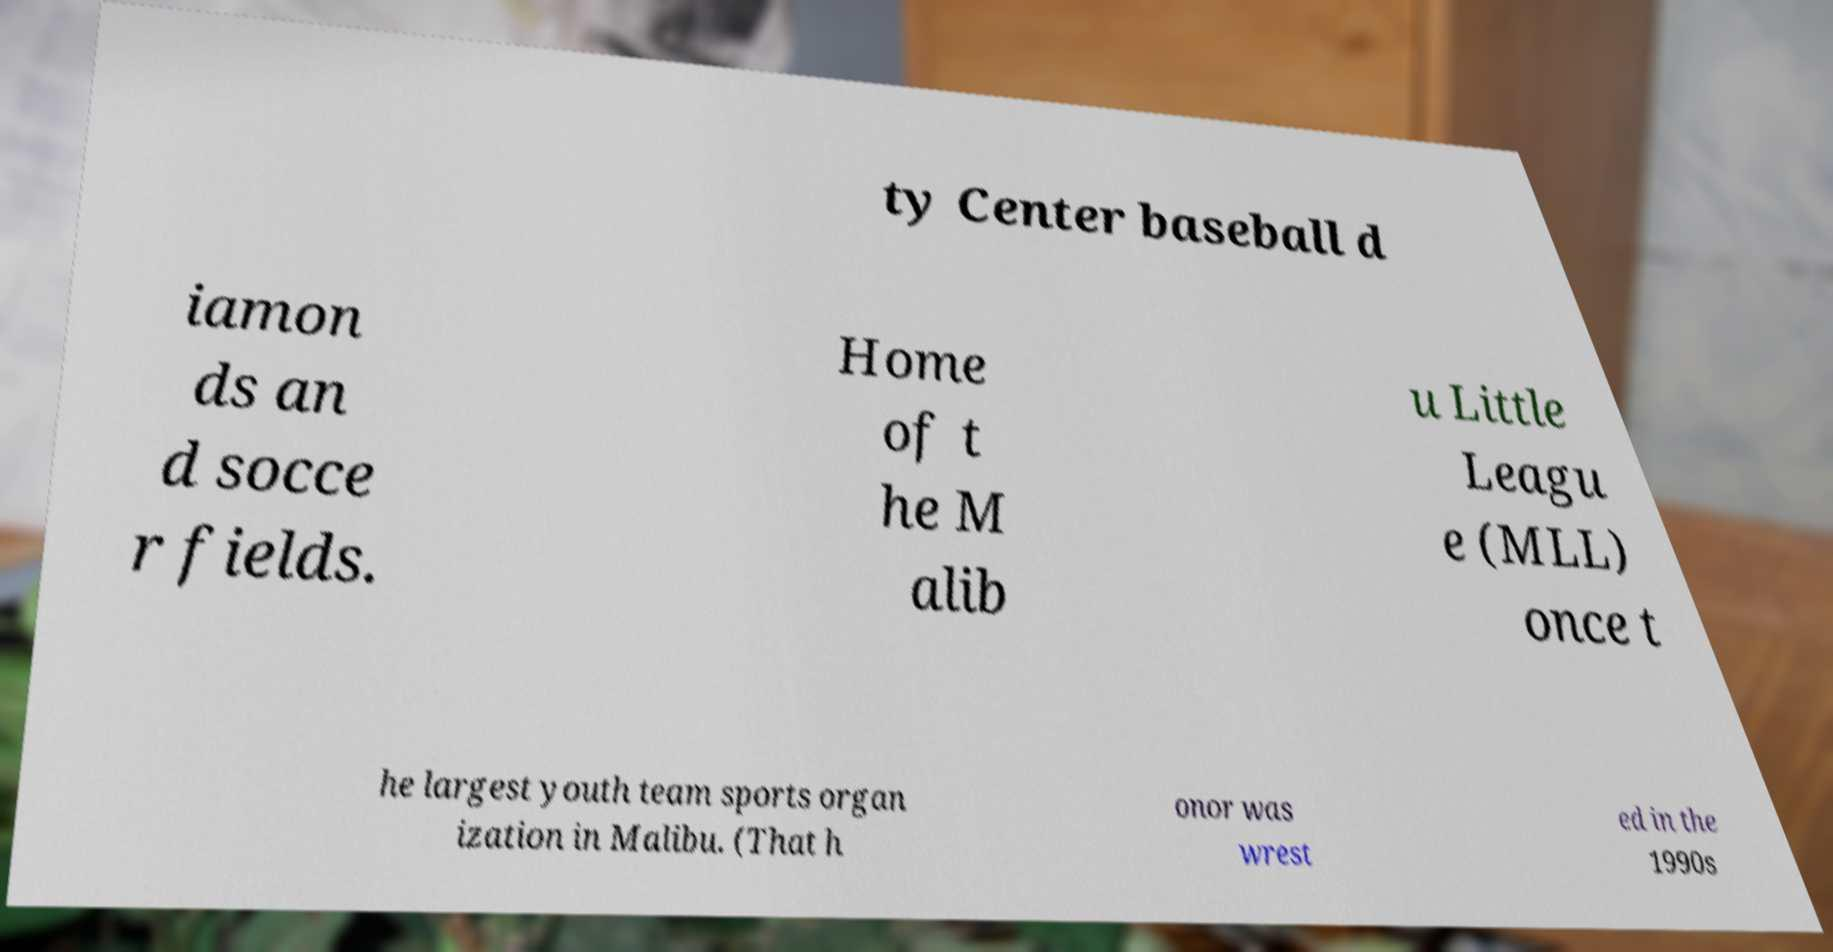There's text embedded in this image that I need extracted. Can you transcribe it verbatim? ty Center baseball d iamon ds an d socce r fields. Home of t he M alib u Little Leagu e (MLL) once t he largest youth team sports organ ization in Malibu. (That h onor was wrest ed in the 1990s 